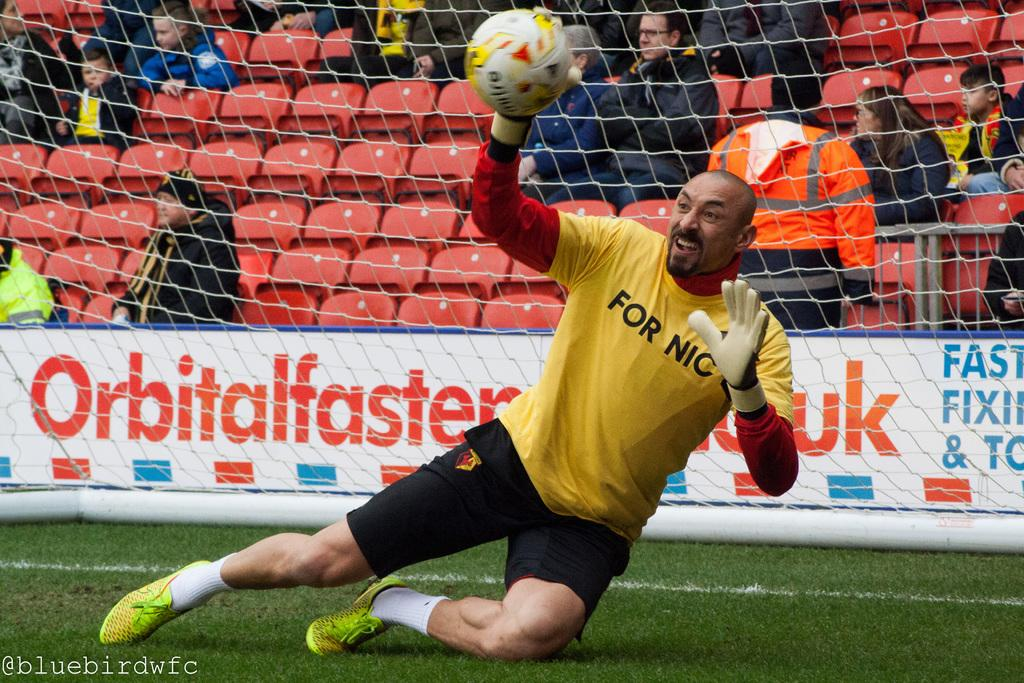Who is the main subject in the image? There is a man in the image. What is the man doing in the image? The man is stopping a ball in the image. What else can be seen in the image besides the man and the ball? There is a net and people sitting on chairs in the image. Where is the pocket located on the horse in the image? There is no horse present in the image, so there is no pocket on a horse to be found. 